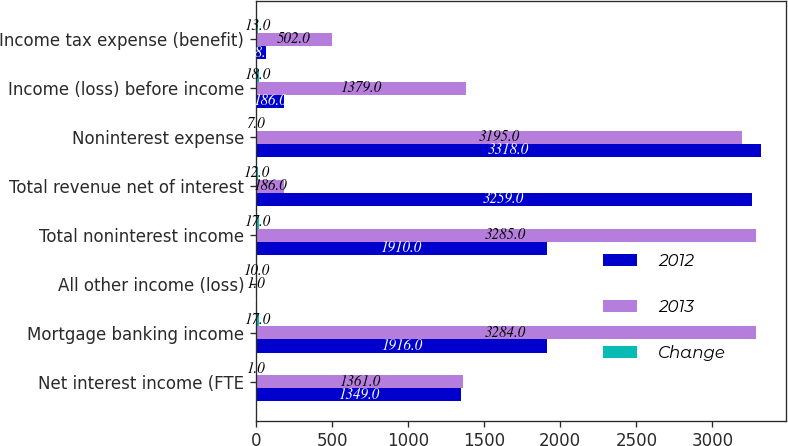Convert chart to OTSL. <chart><loc_0><loc_0><loc_500><loc_500><stacked_bar_chart><ecel><fcel>Net interest income (FTE<fcel>Mortgage banking income<fcel>All other income (loss)<fcel>Total noninterest income<fcel>Total revenue net of interest<fcel>Noninterest expense<fcel>Income (loss) before income<fcel>Income tax expense (benefit)<nl><fcel>2012<fcel>1349<fcel>1916<fcel>6<fcel>1910<fcel>3259<fcel>3318<fcel>186<fcel>68<nl><fcel>2013<fcel>1361<fcel>3284<fcel>1<fcel>3285<fcel>186<fcel>3195<fcel>1379<fcel>502<nl><fcel>Change<fcel>1<fcel>17<fcel>10<fcel>17<fcel>12<fcel>7<fcel>18<fcel>13<nl></chart> 